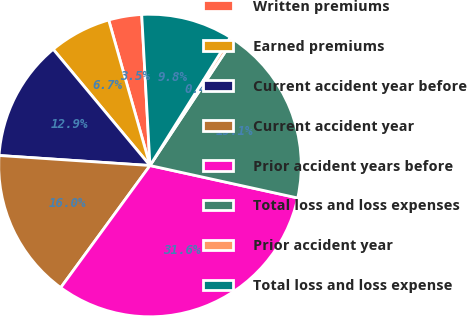Convert chart. <chart><loc_0><loc_0><loc_500><loc_500><pie_chart><fcel>Written premiums<fcel>Earned premiums<fcel>Current accident year before<fcel>Current accident year<fcel>Prior accident years before<fcel>Total loss and loss expenses<fcel>Prior accident year<fcel>Total loss and loss expense<nl><fcel>3.53%<fcel>6.65%<fcel>12.89%<fcel>16.01%<fcel>31.6%<fcel>19.13%<fcel>0.41%<fcel>9.77%<nl></chart> 